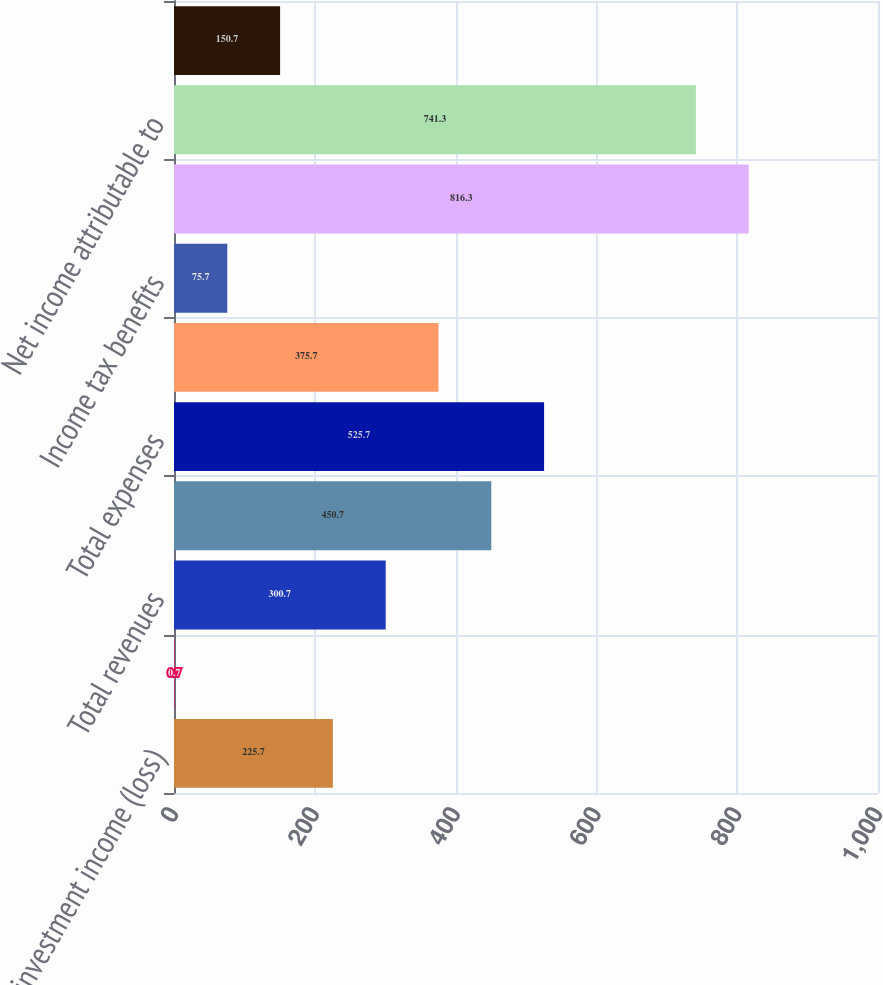Convert chart to OTSL. <chart><loc_0><loc_0><loc_500><loc_500><bar_chart><fcel>Net investment income (loss)<fcel>Net realized capital gains<fcel>Total revenues<fcel>Other operating costs and<fcel>Total expenses<fcel>Losses before income taxes<fcel>Income tax benefits<fcel>Equity in the net income of<fcel>Net income attributable to<fcel>Preferred stock dividends<nl><fcel>225.7<fcel>0.7<fcel>300.7<fcel>450.7<fcel>525.7<fcel>375.7<fcel>75.7<fcel>816.3<fcel>741.3<fcel>150.7<nl></chart> 